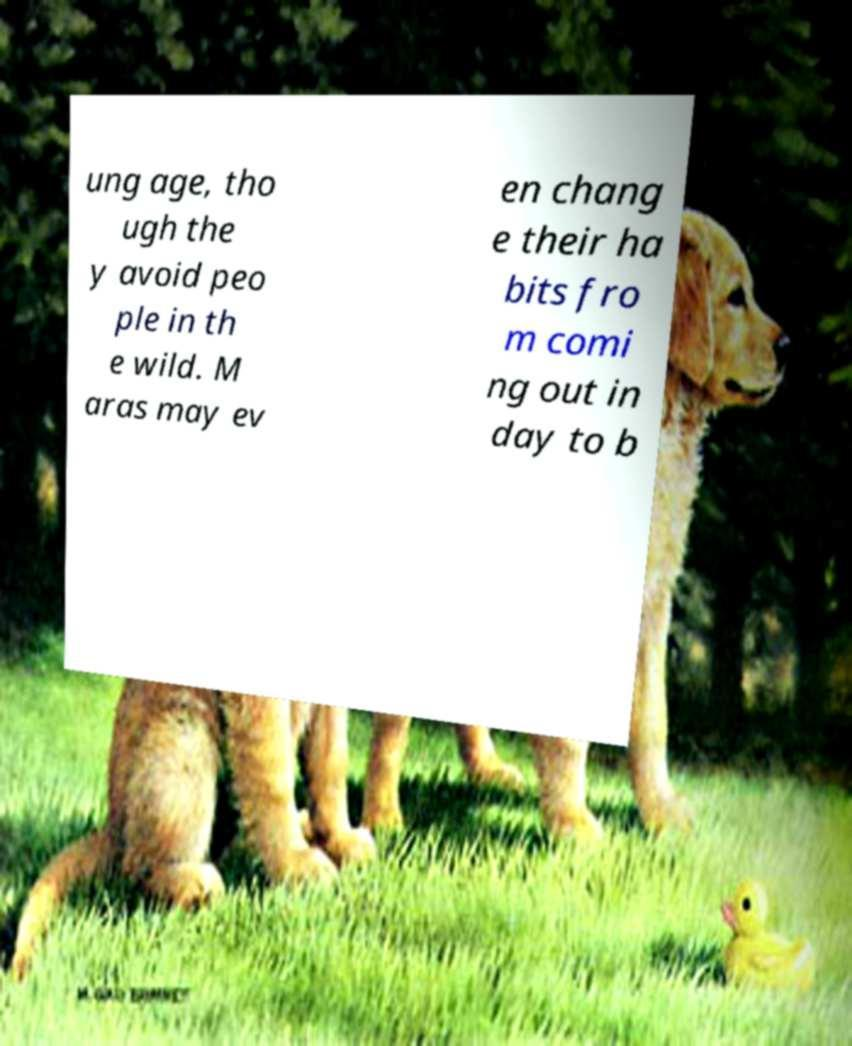Please identify and transcribe the text found in this image. ung age, tho ugh the y avoid peo ple in th e wild. M aras may ev en chang e their ha bits fro m comi ng out in day to b 